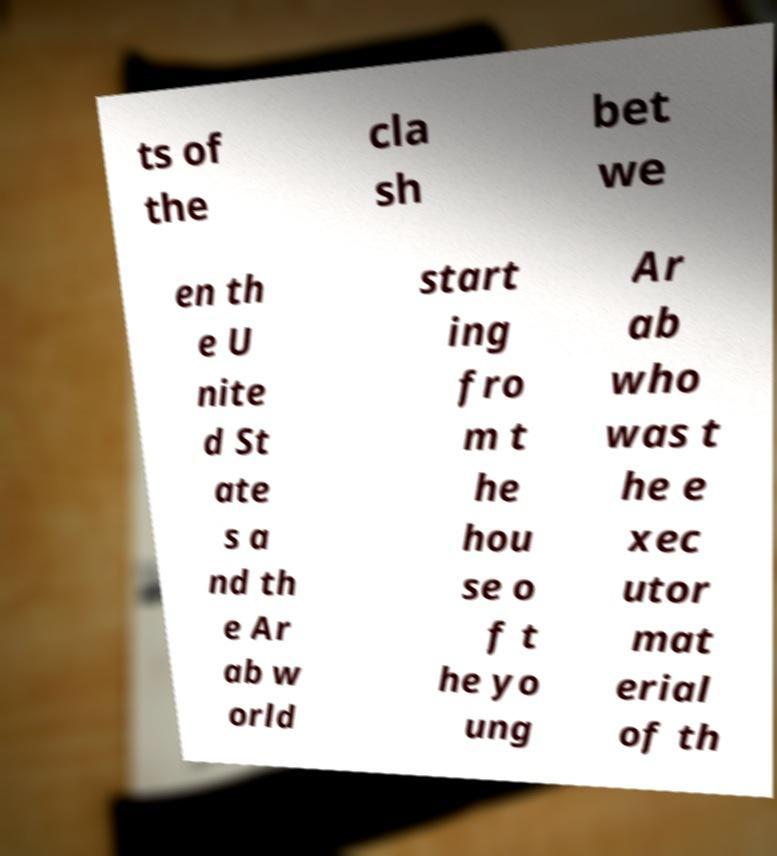What messages or text are displayed in this image? I need them in a readable, typed format. ts of the cla sh bet we en th e U nite d St ate s a nd th e Ar ab w orld start ing fro m t he hou se o f t he yo ung Ar ab who was t he e xec utor mat erial of th 